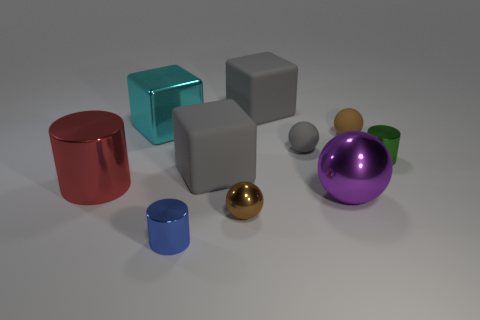Subtract all gray rubber blocks. How many blocks are left? 1 Subtract all purple spheres. How many spheres are left? 3 Subtract 0 green cubes. How many objects are left? 10 Subtract all cubes. How many objects are left? 7 Subtract 3 cylinders. How many cylinders are left? 0 Subtract all red balls. Subtract all cyan blocks. How many balls are left? 4 Subtract all yellow spheres. How many blue cylinders are left? 1 Subtract all small brown metal spheres. Subtract all metal spheres. How many objects are left? 7 Add 8 blue cylinders. How many blue cylinders are left? 9 Add 1 yellow things. How many yellow things exist? 1 